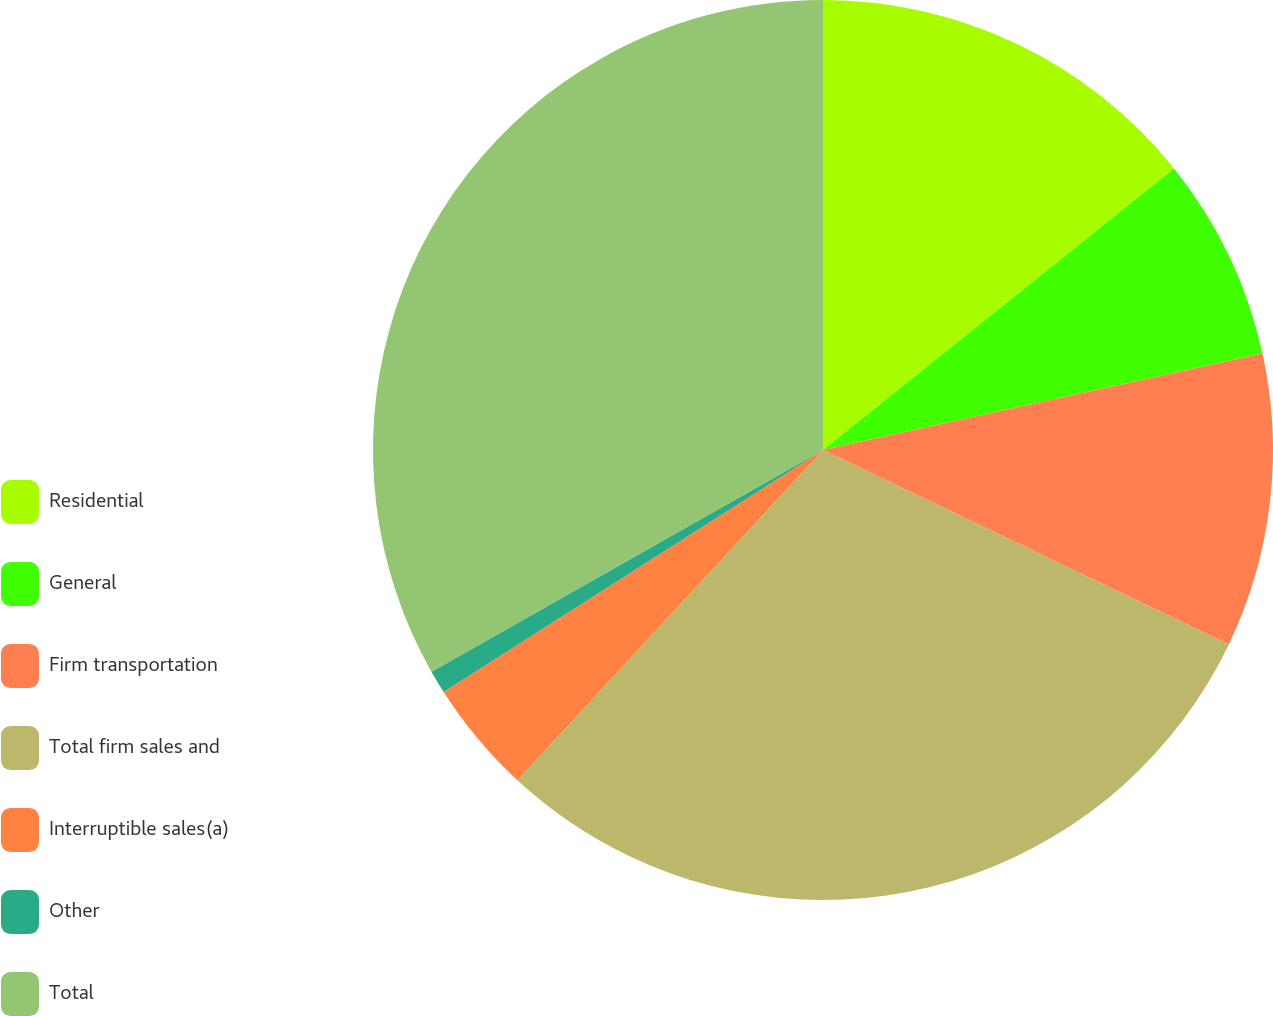Convert chart. <chart><loc_0><loc_0><loc_500><loc_500><pie_chart><fcel>Residential<fcel>General<fcel>Firm transportation<fcel>Total firm sales and<fcel>Interruptible sales(a)<fcel>Other<fcel>Total<nl><fcel>14.24%<fcel>7.32%<fcel>10.55%<fcel>29.77%<fcel>4.08%<fcel>0.84%<fcel>33.2%<nl></chart> 